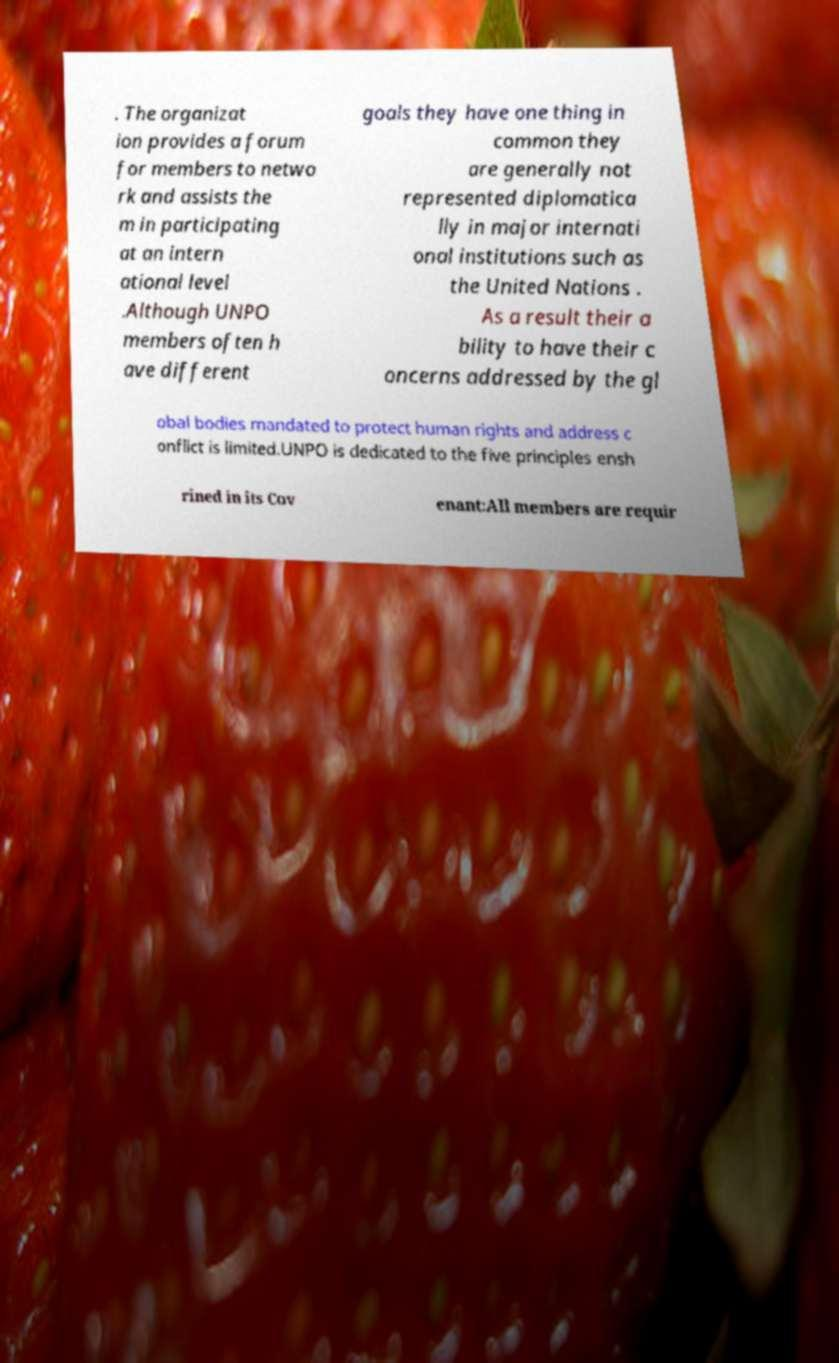I need the written content from this picture converted into text. Can you do that? . The organizat ion provides a forum for members to netwo rk and assists the m in participating at an intern ational level .Although UNPO members often h ave different goals they have one thing in common they are generally not represented diplomatica lly in major internati onal institutions such as the United Nations . As a result their a bility to have their c oncerns addressed by the gl obal bodies mandated to protect human rights and address c onflict is limited.UNPO is dedicated to the five principles ensh rined in its Cov enant:All members are requir 